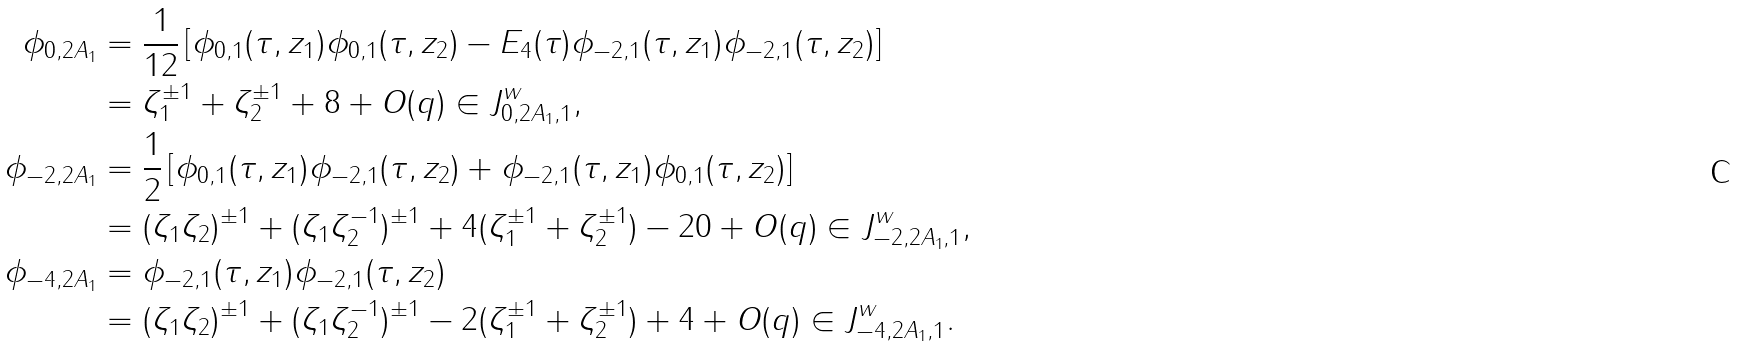<formula> <loc_0><loc_0><loc_500><loc_500>\phi _ { 0 , 2 A _ { 1 } } & = \frac { 1 } { 1 2 } \left [ \phi _ { 0 , 1 } ( \tau , z _ { 1 } ) \phi _ { 0 , 1 } ( \tau , z _ { 2 } ) - E _ { 4 } ( \tau ) \phi _ { - 2 , 1 } ( \tau , z _ { 1 } ) \phi _ { - 2 , 1 } ( \tau , z _ { 2 } ) \right ] \\ & = \zeta _ { 1 } ^ { \pm 1 } + \zeta _ { 2 } ^ { \pm 1 } + 8 + O ( q ) \in J _ { 0 , 2 A _ { 1 } , 1 } ^ { w } , \\ \phi _ { - 2 , 2 A _ { 1 } } & = \frac { 1 } { 2 } \left [ \phi _ { 0 , 1 } ( \tau , z _ { 1 } ) \phi _ { - 2 , 1 } ( \tau , z _ { 2 } ) + \phi _ { - 2 , 1 } ( \tau , z _ { 1 } ) \phi _ { 0 , 1 } ( \tau , z _ { 2 } ) \right ] \\ & = ( \zeta _ { 1 } \zeta _ { 2 } ) ^ { \pm 1 } + ( \zeta _ { 1 } \zeta _ { 2 } ^ { - 1 } ) ^ { \pm 1 } + 4 ( \zeta _ { 1 } ^ { \pm 1 } + \zeta _ { 2 } ^ { \pm 1 } ) - 2 0 + O ( q ) \in J _ { - 2 , 2 A _ { 1 } , 1 } ^ { w } , \\ \phi _ { - 4 , 2 A _ { 1 } } & = \phi _ { - 2 , 1 } ( \tau , z _ { 1 } ) \phi _ { - 2 , 1 } ( \tau , z _ { 2 } ) \\ & = ( \zeta _ { 1 } \zeta _ { 2 } ) ^ { \pm 1 } + ( \zeta _ { 1 } \zeta _ { 2 } ^ { - 1 } ) ^ { \pm 1 } - 2 ( \zeta _ { 1 } ^ { \pm 1 } + \zeta _ { 2 } ^ { \pm 1 } ) + 4 + O ( q ) \in J _ { - 4 , 2 A _ { 1 } , 1 } ^ { w } .</formula> 